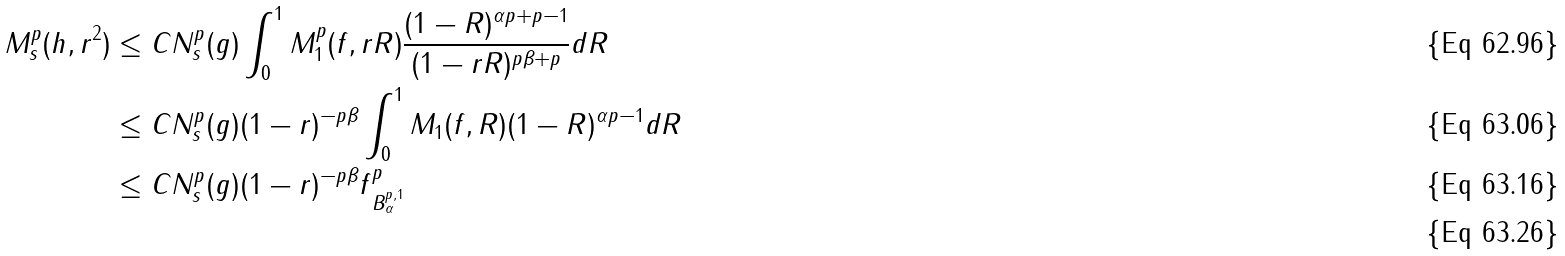Convert formula to latex. <formula><loc_0><loc_0><loc_500><loc_500>M _ { s } ^ { p } ( h , r ^ { 2 } ) & \leq C N _ { s } ^ { p } ( g ) \int _ { 0 } ^ { 1 } M _ { 1 } ^ { p } ( f , r R ) \frac { ( 1 - R ) ^ { \alpha p + p - 1 } } { ( 1 - r R ) ^ { p \beta + p } } d R \\ & \leq C N _ { s } ^ { p } ( g ) ( 1 - r ) ^ { - p \beta } \int _ { 0 } ^ { 1 } M _ { 1 } ( f , R ) ( 1 - R ) ^ { \alpha p - 1 } d R \\ & \leq C N _ { s } ^ { p } ( g ) ( 1 - r ) ^ { - p \beta } \| f \| _ { B ^ { p , 1 } _ { \alpha } } ^ { p } \\</formula> 